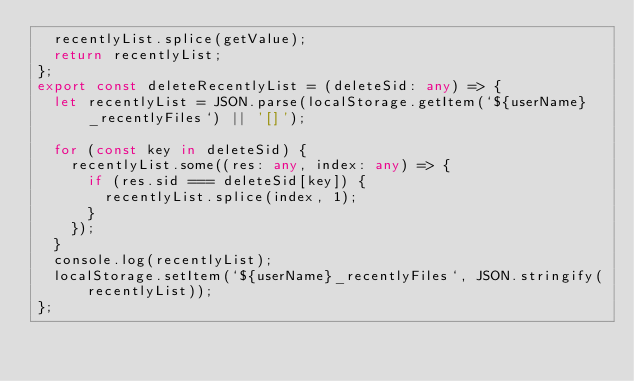Convert code to text. <code><loc_0><loc_0><loc_500><loc_500><_TypeScript_>  recentlyList.splice(getValue);
  return recentlyList;
};
export const deleteRecentlyList = (deleteSid: any) => {
  let recentlyList = JSON.parse(localStorage.getItem(`${userName}_recentlyFiles`) || '[]');

  for (const key in deleteSid) {
    recentlyList.some((res: any, index: any) => {
      if (res.sid === deleteSid[key]) {
        recentlyList.splice(index, 1);
      }
    });
  }
  console.log(recentlyList);
  localStorage.setItem(`${userName}_recentlyFiles`, JSON.stringify(recentlyList));
};
</code> 